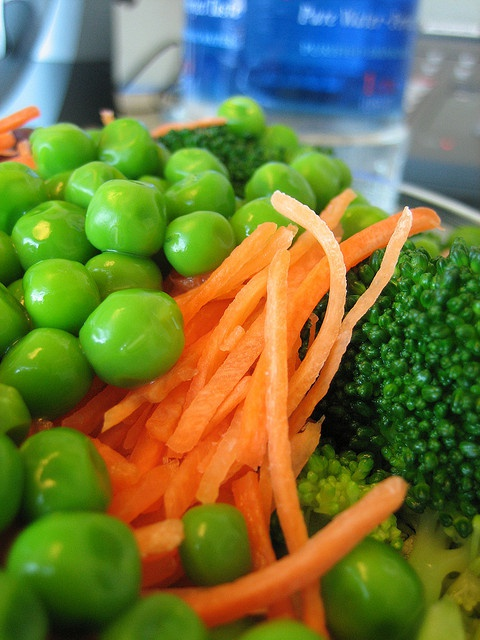Describe the objects in this image and their specific colors. I can see broccoli in ivory, darkgreen, black, and green tones, carrot in ivory, red, orange, brown, and maroon tones, bottle in ivory, blue, darkgray, and gray tones, carrot in ivory, red, orange, and brown tones, and carrot in ivory, orange, red, and brown tones in this image. 